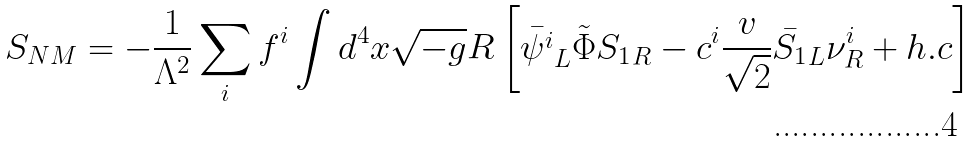Convert formula to latex. <formula><loc_0><loc_0><loc_500><loc_500>S _ { N M } = - \frac { 1 } { \Lambda ^ { 2 } } \sum _ { i } f ^ { i } \int d ^ { 4 } x \sqrt { - g } R \left [ { \bar { \psi ^ { i } } } _ { L } \tilde { \Phi } { S _ { 1 } } _ { R } - c ^ { i } \frac { v } { \sqrt { 2 } } { \bar { S _ { 1 } } _ { L } } \nu ^ { i } _ { R } + h . c \right ]</formula> 